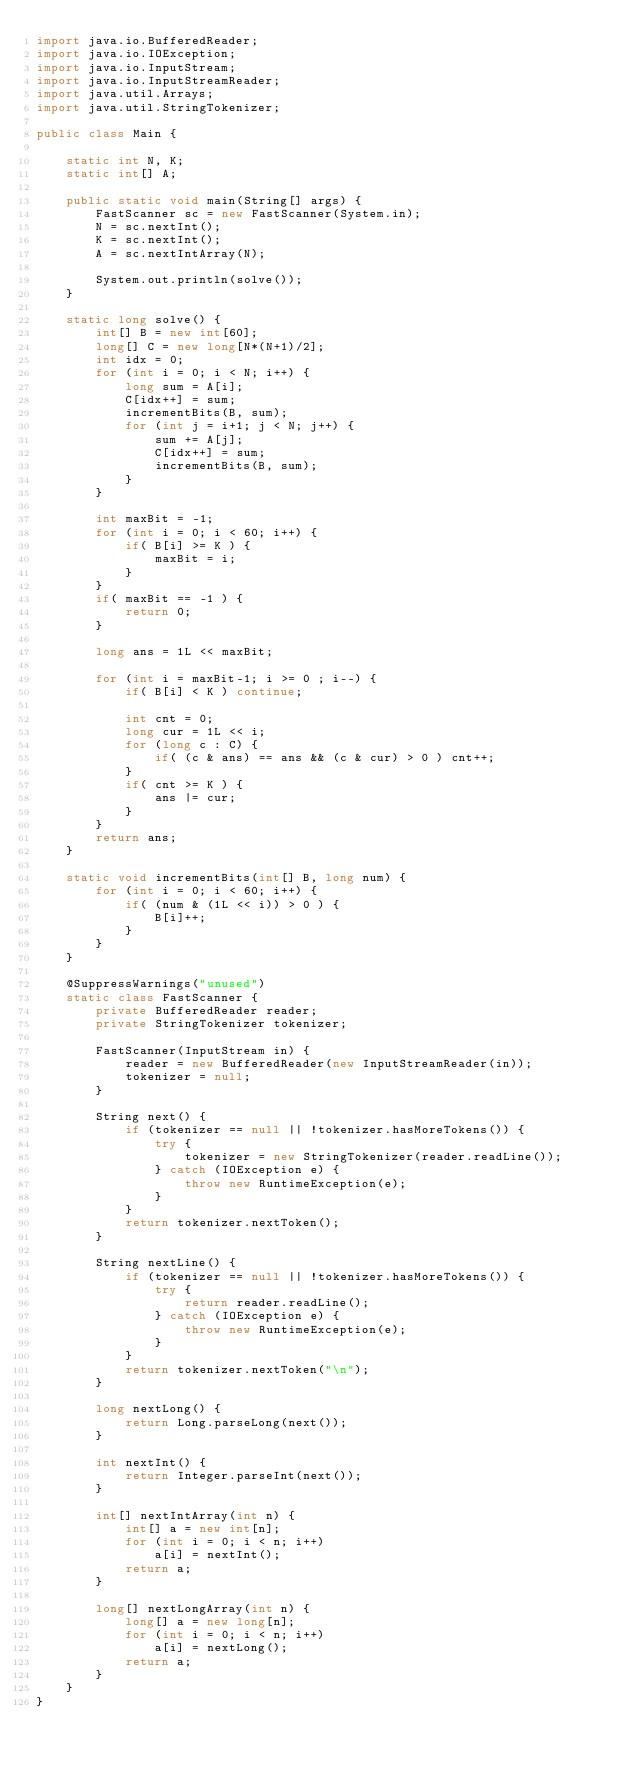Convert code to text. <code><loc_0><loc_0><loc_500><loc_500><_Java_>import java.io.BufferedReader;
import java.io.IOException;
import java.io.InputStream;
import java.io.InputStreamReader;
import java.util.Arrays;
import java.util.StringTokenizer;

public class Main {

    static int N, K;
    static int[] A;

    public static void main(String[] args) {
        FastScanner sc = new FastScanner(System.in);
        N = sc.nextInt();
        K = sc.nextInt();
        A = sc.nextIntArray(N);

        System.out.println(solve());
    }

    static long solve() {
        int[] B = new int[60];
        long[] C = new long[N*(N+1)/2];
        int idx = 0;
        for (int i = 0; i < N; i++) {
            long sum = A[i];
            C[idx++] = sum;
            incrementBits(B, sum);
            for (int j = i+1; j < N; j++) {
                sum += A[j];
                C[idx++] = sum;
                incrementBits(B, sum);
            }
        }

        int maxBit = -1;
        for (int i = 0; i < 60; i++) {
            if( B[i] >= K ) {
                maxBit = i;
            }
        }
        if( maxBit == -1 ) {
            return 0;
        }

        long ans = 1L << maxBit;

        for (int i = maxBit-1; i >= 0 ; i--) {
            if( B[i] < K ) continue;

            int cnt = 0;
            long cur = 1L << i;
            for (long c : C) {
                if( (c & ans) == ans && (c & cur) > 0 ) cnt++;
            }
            if( cnt >= K ) {
                ans |= cur;
            }
        }
        return ans;
    }

    static void incrementBits(int[] B, long num) {
        for (int i = 0; i < 60; i++) {
            if( (num & (1L << i)) > 0 ) {
                B[i]++;
            }
        }
    }

    @SuppressWarnings("unused")
    static class FastScanner {
        private BufferedReader reader;
        private StringTokenizer tokenizer;

        FastScanner(InputStream in) {
            reader = new BufferedReader(new InputStreamReader(in));
            tokenizer = null;
        }

        String next() {
            if (tokenizer == null || !tokenizer.hasMoreTokens()) {
                try {
                    tokenizer = new StringTokenizer(reader.readLine());
                } catch (IOException e) {
                    throw new RuntimeException(e);
                }
            }
            return tokenizer.nextToken();
        }

        String nextLine() {
            if (tokenizer == null || !tokenizer.hasMoreTokens()) {
                try {
                    return reader.readLine();
                } catch (IOException e) {
                    throw new RuntimeException(e);
                }
            }
            return tokenizer.nextToken("\n");
        }

        long nextLong() {
            return Long.parseLong(next());
        }

        int nextInt() {
            return Integer.parseInt(next());
        }

        int[] nextIntArray(int n) {
            int[] a = new int[n];
            for (int i = 0; i < n; i++)
                a[i] = nextInt();
            return a;
        }

        long[] nextLongArray(int n) {
            long[] a = new long[n];
            for (int i = 0; i < n; i++)
                a[i] = nextLong();
            return a;
        }
    }
}
</code> 